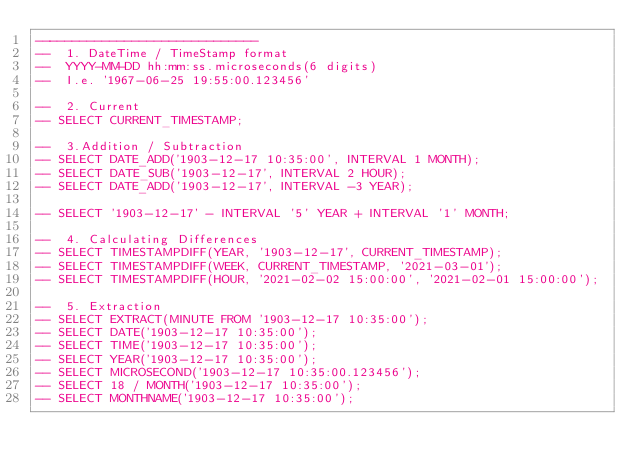<code> <loc_0><loc_0><loc_500><loc_500><_SQL_>------------------------------
-- 	1. DateTime / TimeStamp format
-- 	YYYY-MM-DD hh:mm:ss.microseconds(6 digits)
-- 	I.e. '1967-06-25 19:55:00.123456'

-- 	2. Current
-- SELECT CURRENT_TIMESTAMP;

-- 	3.Addition / Subtraction
-- SELECT DATE_ADD('1903-12-17 10:35:00', INTERVAL 1 MONTH);
-- SELECT DATE_SUB('1903-12-17', INTERVAL 2 HOUR);
-- SELECT DATE_ADD('1903-12-17', INTERVAL -3 YEAR);

-- SELECT '1903-12-17' - INTERVAL '5' YEAR + INTERVAL '1' MONTH;

-- 	4. Calculating Differences
-- SELECT TIMESTAMPDIFF(YEAR, '1903-12-17', CURRENT_TIMESTAMP);
-- SELECT TIMESTAMPDIFF(WEEK, CURRENT_TIMESTAMP, '2021-03-01');
-- SELECT TIMESTAMPDIFF(HOUR, '2021-02-02 15:00:00', '2021-02-01 15:00:00'); 

-- 	5. Extraction
-- SELECT EXTRACT(MINUTE FROM '1903-12-17 10:35:00');
-- SELECT DATE('1903-12-17 10:35:00');
-- SELECT TIME('1903-12-17 10:35:00');
-- SELECT YEAR('1903-12-17 10:35:00');
-- SELECT MICROSECOND('1903-12-17 10:35:00.123456');
-- SELECT 18 / MONTH('1903-12-17 10:35:00');
-- SELECT MONTHNAME('1903-12-17 10:35:00');</code> 